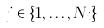<formula> <loc_0><loc_0><loc_500><loc_500>j \in \{ 1 , \dots , N _ { i } \}</formula> 